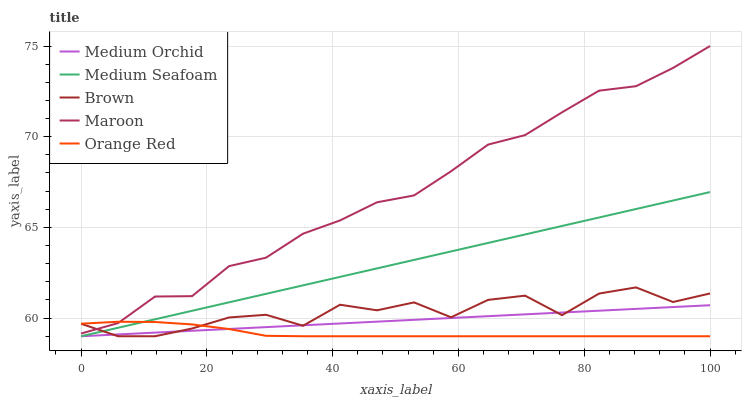Does Orange Red have the minimum area under the curve?
Answer yes or no. Yes. Does Maroon have the maximum area under the curve?
Answer yes or no. Yes. Does Medium Orchid have the minimum area under the curve?
Answer yes or no. No. Does Medium Orchid have the maximum area under the curve?
Answer yes or no. No. Is Medium Orchid the smoothest?
Answer yes or no. Yes. Is Brown the roughest?
Answer yes or no. Yes. Is Medium Seafoam the smoothest?
Answer yes or no. No. Is Medium Seafoam the roughest?
Answer yes or no. No. Does Brown have the lowest value?
Answer yes or no. Yes. Does Maroon have the lowest value?
Answer yes or no. No. Does Maroon have the highest value?
Answer yes or no. Yes. Does Medium Orchid have the highest value?
Answer yes or no. No. Is Medium Seafoam less than Maroon?
Answer yes or no. Yes. Is Maroon greater than Medium Seafoam?
Answer yes or no. Yes. Does Orange Red intersect Brown?
Answer yes or no. Yes. Is Orange Red less than Brown?
Answer yes or no. No. Is Orange Red greater than Brown?
Answer yes or no. No. Does Medium Seafoam intersect Maroon?
Answer yes or no. No. 